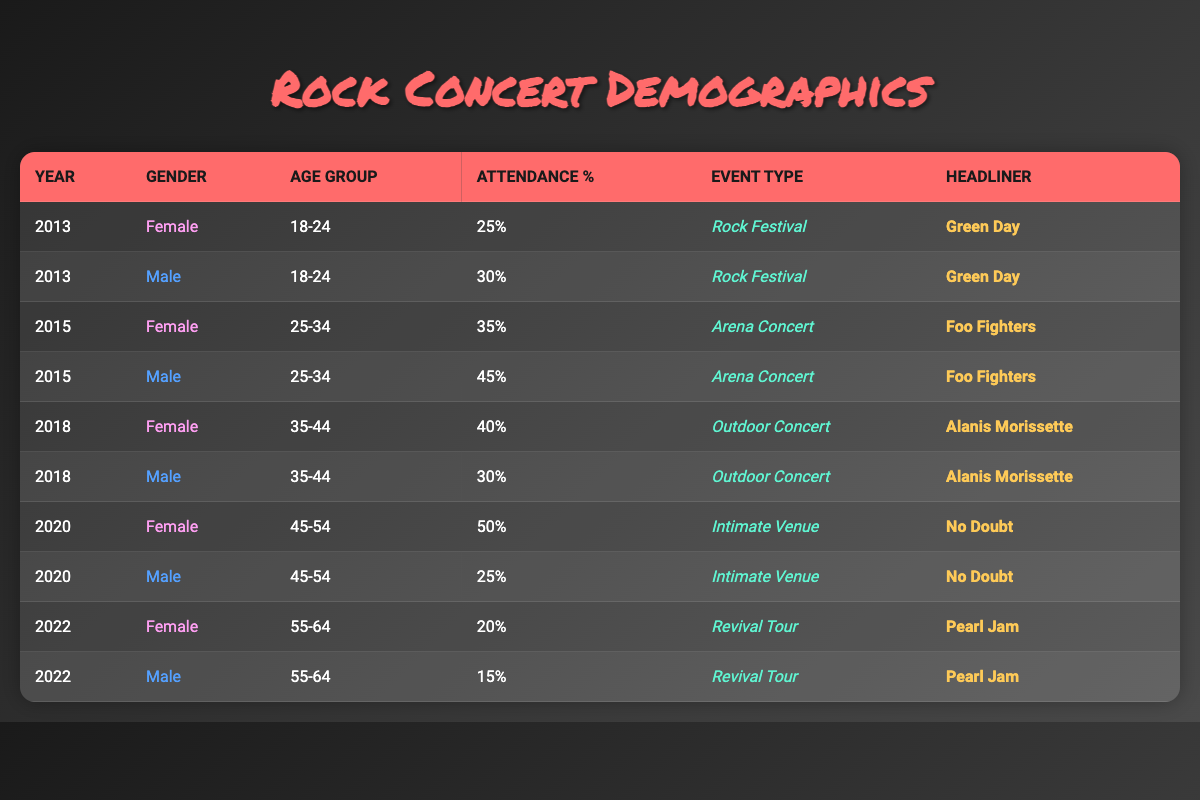What was the attendance percentage of female concert attendees in 2013? In 2013, the table shows that the attendance percentage of female concert attendees aged 18-24 was 25%.
Answer: 25% What was the headliner for the 2015 Arena Concert? According to the table, the headliner for the 2015 Arena Concert was the Foo Fighters.
Answer: Foo Fighters What is the attendance percentage difference between male and female attendees aged 25-34 in 2015? In 2015, female attendees aged 25-34 had an attendance percentage of 35%, while male attendees had 45%. The difference is 45 - 35 = 10%.
Answer: 10% Did more female or male attendees aged 45-54 attend the concert in 2020? The data shows that in 2020, 50% of female attendees aged 45-54 attended the concert, compared to 25% of male attendees. Therefore, more females attended the concert.
Answer: Yes What was the overall trend in attendance for females aged 55-64 from 2020 to 2022? The table indicates that in 2020, 50% of female attendees aged 45-54 were present, whereas in 2022, only 20% of females aged 55-64 attended. This shows a decline in attendance.
Answer: Decline What age group had the highest attendance percentage for males in 2015? In 2015, males aged 25-34 had the highest attendance percentage at 45%.
Answer: 25-34 What was the total attendance percentage of female attendees across all years listed? The attendance percentages for females are 25% (2013) + 35% (2015) + 40% (2018) + 50% (2020) + 20% (2022) = 200%. The total attendance percentage across all years is 200%.
Answer: 200% In which year did male attendees aged 35-44 have the lowest attendance percentage? According to the data, male attendees aged 35-44 had the lowest attendance at 30% in the year 2018.
Answer: 2018 Overall, what percentage of female attendees was recorded at the Revival Tour in 2022? In 2022, the percentage of female attendees at the Revival Tour was 20%.
Answer: 20% 